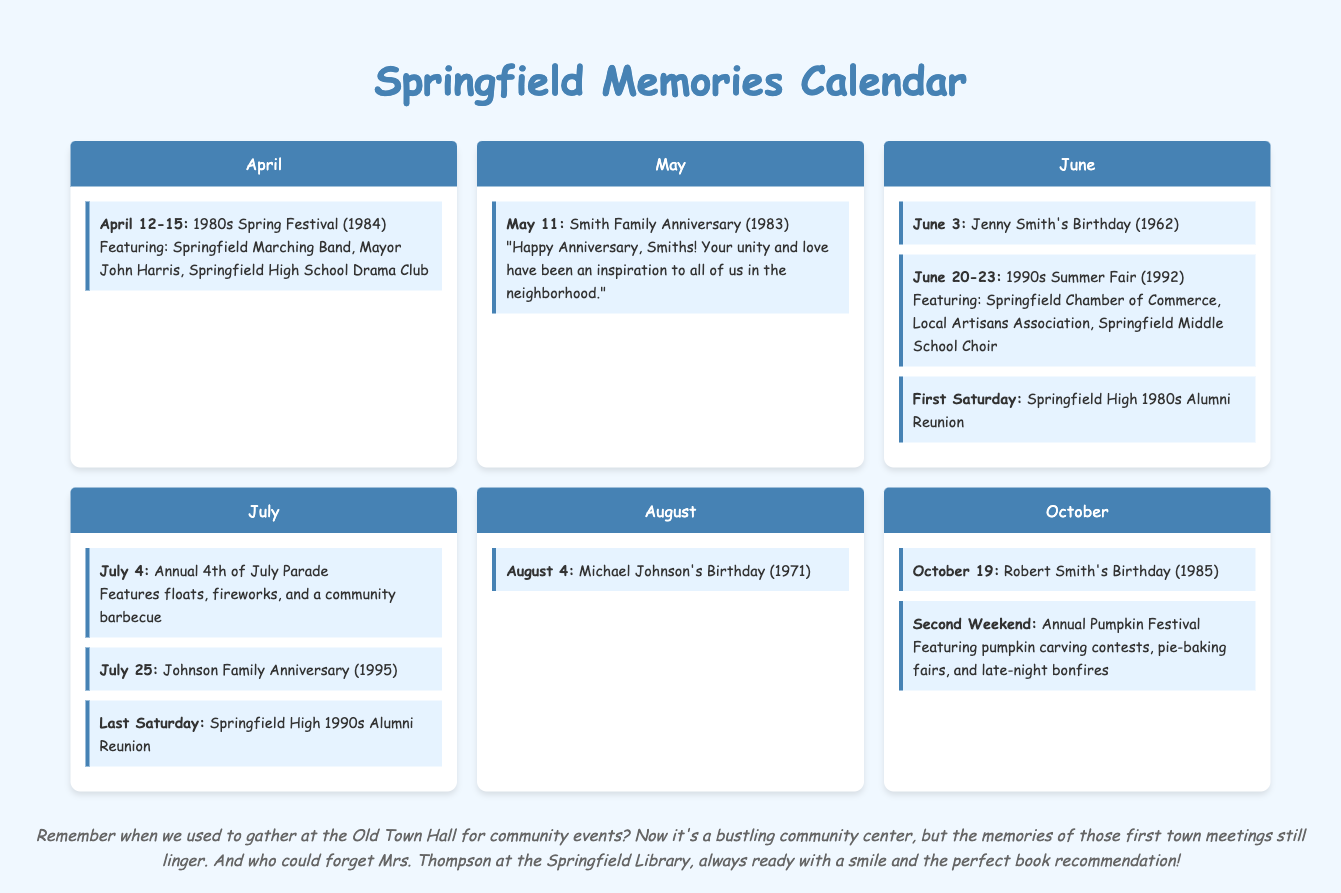What dates did the 1980s Spring Festival occur? The 1980s Spring Festival took place from April 12-15 in 1984.
Answer: April 12-15 Who were featured in the 1990s Summer Fair? The 1990s Summer Fair featured the Springfield Chamber of Commerce, Local Artisans Association, and Springfield Middle School Choir.
Answer: Springfield Chamber of Commerce, Local Artisans Association, Springfield Middle School Choir When is Jenny Smith's birthday? Jenny Smith's birthday is on June 3, 1962.
Answer: June 3 What is celebrated on July 4th? July 4th celebrates the Annual 4th of July Parade.
Answer: Annual 4th of July Parade What month has the Annual Pumpkin Festival? The Annual Pumpkin Festival occurs in October.
Answer: October Which family celebrates their anniversary on May 11? The Smith Family celebrates their anniversary on May 11, 1983.
Answer: Smith Family When is the Springfield High 1980s Alumni Reunion held? The Springfield High 1980s Alumni Reunion is held on the first Saturday of June.
Answer: First Saturday What does the document highlight about the Old Town Hall? The document mentions that the Old Town Hall has turned into a bustling community center.
Answer: Bustling community center 